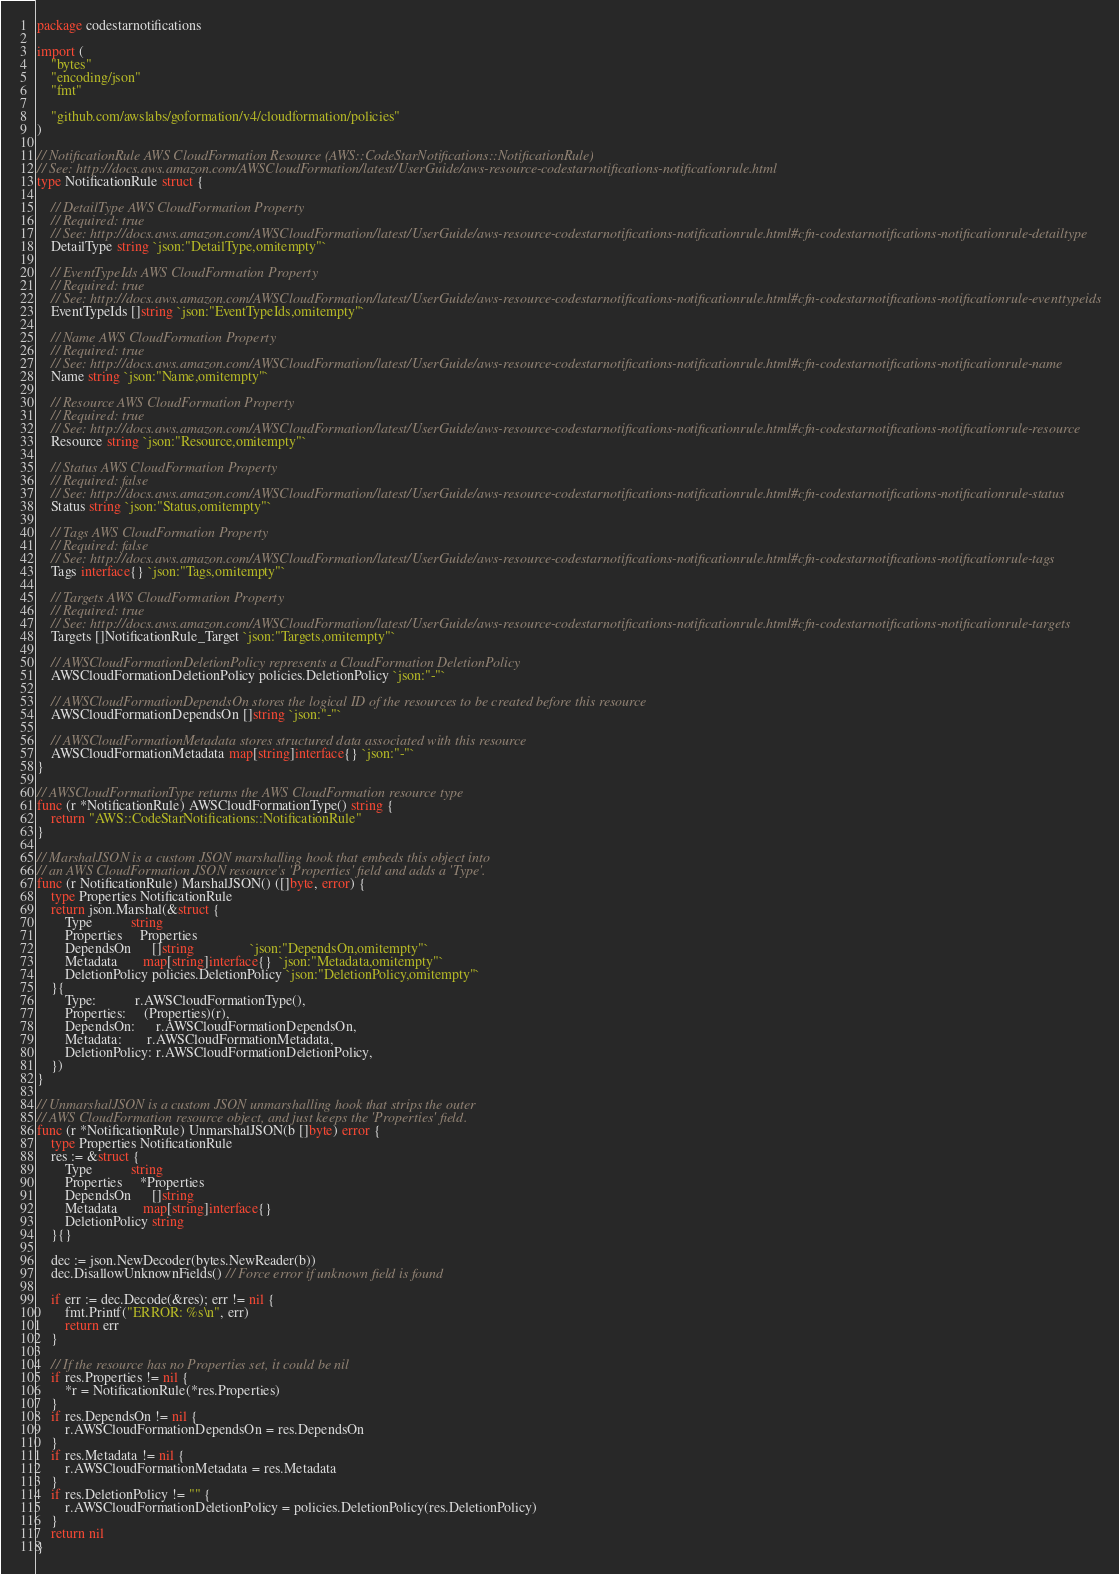<code> <loc_0><loc_0><loc_500><loc_500><_Go_>package codestarnotifications

import (
	"bytes"
	"encoding/json"
	"fmt"

	"github.com/awslabs/goformation/v4/cloudformation/policies"
)

// NotificationRule AWS CloudFormation Resource (AWS::CodeStarNotifications::NotificationRule)
// See: http://docs.aws.amazon.com/AWSCloudFormation/latest/UserGuide/aws-resource-codestarnotifications-notificationrule.html
type NotificationRule struct {

	// DetailType AWS CloudFormation Property
	// Required: true
	// See: http://docs.aws.amazon.com/AWSCloudFormation/latest/UserGuide/aws-resource-codestarnotifications-notificationrule.html#cfn-codestarnotifications-notificationrule-detailtype
	DetailType string `json:"DetailType,omitempty"`

	// EventTypeIds AWS CloudFormation Property
	// Required: true
	// See: http://docs.aws.amazon.com/AWSCloudFormation/latest/UserGuide/aws-resource-codestarnotifications-notificationrule.html#cfn-codestarnotifications-notificationrule-eventtypeids
	EventTypeIds []string `json:"EventTypeIds,omitempty"`

	// Name AWS CloudFormation Property
	// Required: true
	// See: http://docs.aws.amazon.com/AWSCloudFormation/latest/UserGuide/aws-resource-codestarnotifications-notificationrule.html#cfn-codestarnotifications-notificationrule-name
	Name string `json:"Name,omitempty"`

	// Resource AWS CloudFormation Property
	// Required: true
	// See: http://docs.aws.amazon.com/AWSCloudFormation/latest/UserGuide/aws-resource-codestarnotifications-notificationrule.html#cfn-codestarnotifications-notificationrule-resource
	Resource string `json:"Resource,omitempty"`

	// Status AWS CloudFormation Property
	// Required: false
	// See: http://docs.aws.amazon.com/AWSCloudFormation/latest/UserGuide/aws-resource-codestarnotifications-notificationrule.html#cfn-codestarnotifications-notificationrule-status
	Status string `json:"Status,omitempty"`

	// Tags AWS CloudFormation Property
	// Required: false
	// See: http://docs.aws.amazon.com/AWSCloudFormation/latest/UserGuide/aws-resource-codestarnotifications-notificationrule.html#cfn-codestarnotifications-notificationrule-tags
	Tags interface{} `json:"Tags,omitempty"`

	// Targets AWS CloudFormation Property
	// Required: true
	// See: http://docs.aws.amazon.com/AWSCloudFormation/latest/UserGuide/aws-resource-codestarnotifications-notificationrule.html#cfn-codestarnotifications-notificationrule-targets
	Targets []NotificationRule_Target `json:"Targets,omitempty"`

	// AWSCloudFormationDeletionPolicy represents a CloudFormation DeletionPolicy
	AWSCloudFormationDeletionPolicy policies.DeletionPolicy `json:"-"`

	// AWSCloudFormationDependsOn stores the logical ID of the resources to be created before this resource
	AWSCloudFormationDependsOn []string `json:"-"`

	// AWSCloudFormationMetadata stores structured data associated with this resource
	AWSCloudFormationMetadata map[string]interface{} `json:"-"`
}

// AWSCloudFormationType returns the AWS CloudFormation resource type
func (r *NotificationRule) AWSCloudFormationType() string {
	return "AWS::CodeStarNotifications::NotificationRule"
}

// MarshalJSON is a custom JSON marshalling hook that embeds this object into
// an AWS CloudFormation JSON resource's 'Properties' field and adds a 'Type'.
func (r NotificationRule) MarshalJSON() ([]byte, error) {
	type Properties NotificationRule
	return json.Marshal(&struct {
		Type           string
		Properties     Properties
		DependsOn      []string                `json:"DependsOn,omitempty"`
		Metadata       map[string]interface{}  `json:"Metadata,omitempty"`
		DeletionPolicy policies.DeletionPolicy `json:"DeletionPolicy,omitempty"`
	}{
		Type:           r.AWSCloudFormationType(),
		Properties:     (Properties)(r),
		DependsOn:      r.AWSCloudFormationDependsOn,
		Metadata:       r.AWSCloudFormationMetadata,
		DeletionPolicy: r.AWSCloudFormationDeletionPolicy,
	})
}

// UnmarshalJSON is a custom JSON unmarshalling hook that strips the outer
// AWS CloudFormation resource object, and just keeps the 'Properties' field.
func (r *NotificationRule) UnmarshalJSON(b []byte) error {
	type Properties NotificationRule
	res := &struct {
		Type           string
		Properties     *Properties
		DependsOn      []string
		Metadata       map[string]interface{}
		DeletionPolicy string
	}{}

	dec := json.NewDecoder(bytes.NewReader(b))
	dec.DisallowUnknownFields() // Force error if unknown field is found

	if err := dec.Decode(&res); err != nil {
		fmt.Printf("ERROR: %s\n", err)
		return err
	}

	// If the resource has no Properties set, it could be nil
	if res.Properties != nil {
		*r = NotificationRule(*res.Properties)
	}
	if res.DependsOn != nil {
		r.AWSCloudFormationDependsOn = res.DependsOn
	}
	if res.Metadata != nil {
		r.AWSCloudFormationMetadata = res.Metadata
	}
	if res.DeletionPolicy != "" {
		r.AWSCloudFormationDeletionPolicy = policies.DeletionPolicy(res.DeletionPolicy)
	}
	return nil
}
</code> 